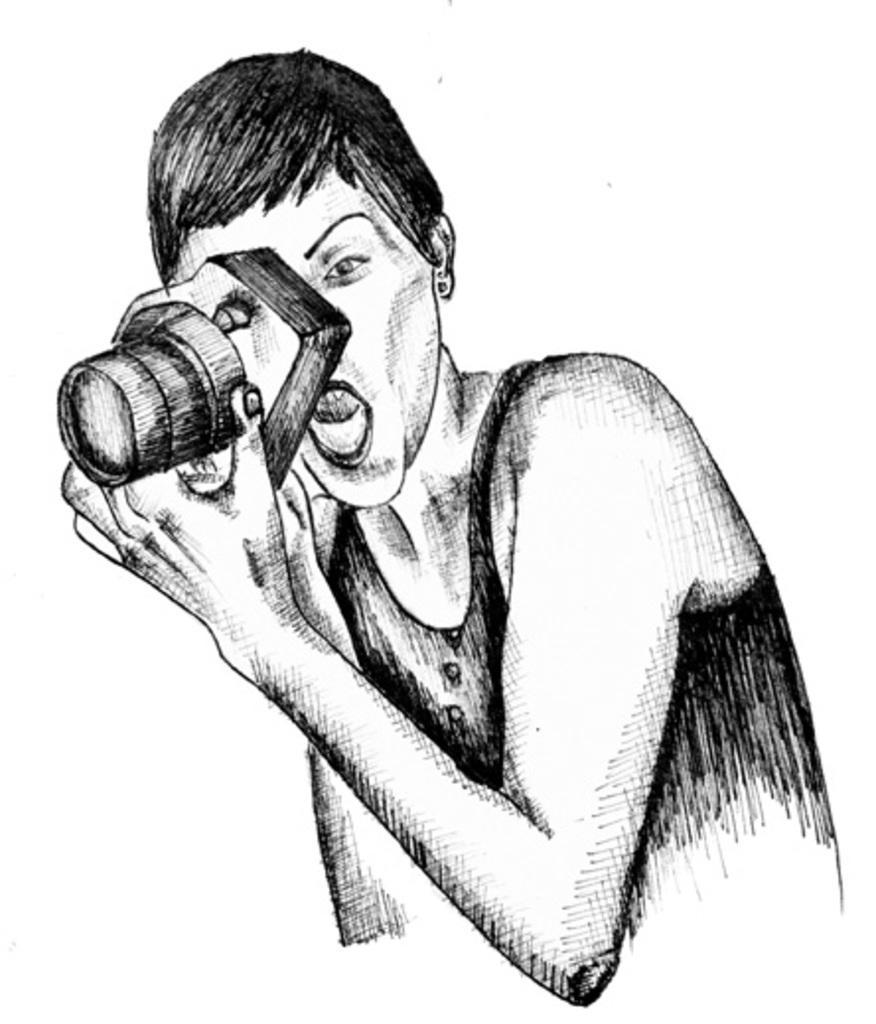In one or two sentences, can you explain what this image depicts? In this image there is a sketch of a lady holding a camera, in her hand. 